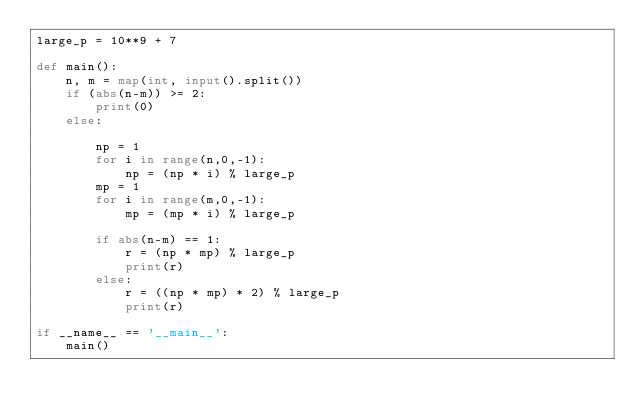<code> <loc_0><loc_0><loc_500><loc_500><_Python_>large_p = 10**9 + 7

def main():
    n, m = map(int, input().split())
    if (abs(n-m)) >= 2:
        print(0)
    else:
        
        np = 1
        for i in range(n,0,-1):
            np = (np * i) % large_p
        mp = 1
        for i in range(m,0,-1):
            mp = (mp * i) % large_p

        if abs(n-m) == 1:
            r = (np * mp) % large_p
            print(r)
        else:
            r = ((np * mp) * 2) % large_p
            print(r)

if __name__ == '__main__':
    main()
</code> 